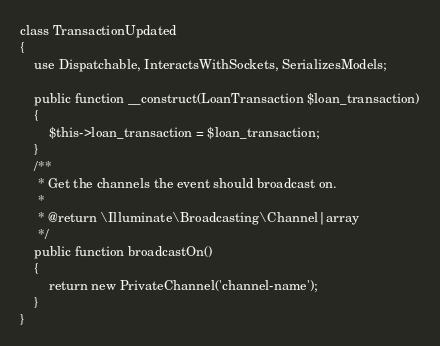Convert code to text. <code><loc_0><loc_0><loc_500><loc_500><_PHP_>
class TransactionUpdated
{
    use Dispatchable, InteractsWithSockets, SerializesModels;

    public function __construct(LoanTransaction $loan_transaction)
    {
        $this->loan_transaction = $loan_transaction;
    }
    /**
     * Get the channels the event should broadcast on.
     *
     * @return \Illuminate\Broadcasting\Channel|array
     */
    public function broadcastOn()
    {
        return new PrivateChannel('channel-name');
    }
}
</code> 